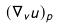Convert formula to latex. <formula><loc_0><loc_0><loc_500><loc_500>( \nabla _ { v } u ) _ { p }</formula> 